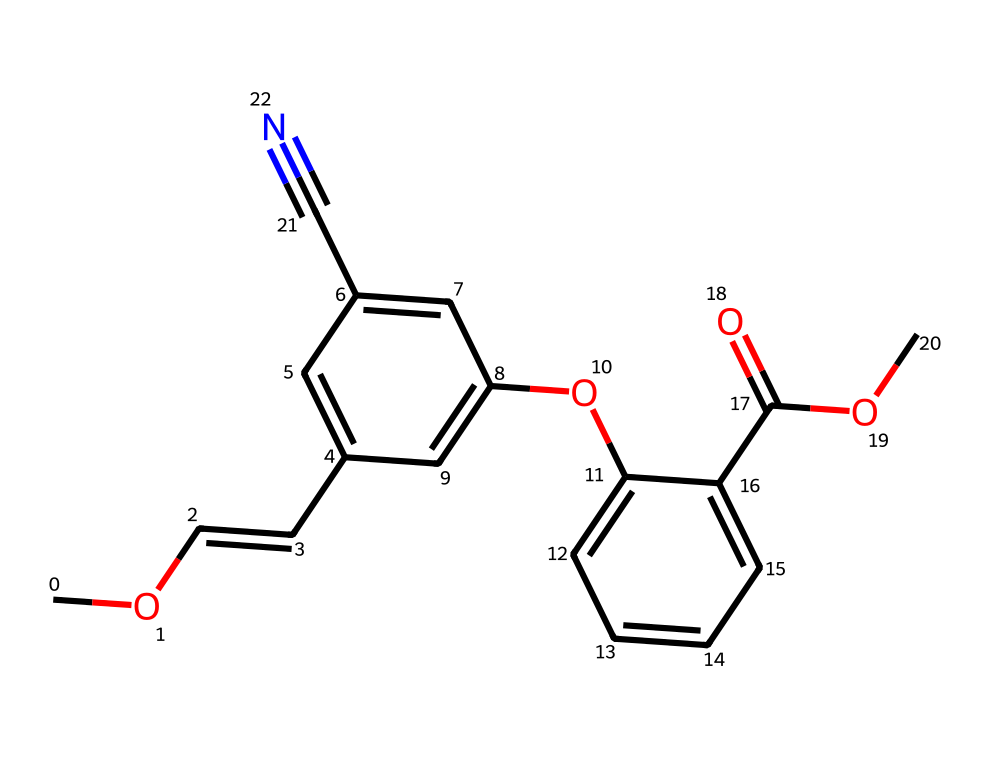What is the molecular formula of azoxystrobin? To determine the molecular formula, we identify and count the various atoms present in the provided SMILES representation. The key elements in the structure include carbon (C), hydrogen (H), oxygen (O), and nitrogen (N). Counting the atoms gives us a formula of C18H18N2O4.
Answer: C18H18N2O4 How many rings are present in the chemical structure of azoxystrobin? By examining the structure in the SMILES notation, we see two cyclic components, specifically located in the occluded aromatic rings. Each benzene-like structure contributes to the total ring count.
Answer: 2 What type of functional groups are present in azoxystrobin? The SMILES includes several functional groups such as an ester group (due to the presence of -COOC) and a cyano group (-C#N). The esters are indicated with the carbon-oxygen bonds and the cyano group is identified by the terminal triple bond with nitrogen.
Answer: ester, cyano What is the significance of the cyano group in azoxystrobin? The cyano group (-C#N) plays a role in the biological activity of azoxystrobin, influencing its toxicity and efficacy against fungal pathogens. It increases the lipophilicity, aiding the penetration of the molecule into fungal cells.
Answer: biological activity Which parts of the azoxystrobin structure are likely responsible for its fungicidal properties? Analyzing the chemical structure and its functional groups, both the aromatic ring system and cyano group contribute to its mechanism of action, specifically through their interactions with fungal enzymes. The steric and electronic properties of these groups help inhibit the fungi's metabolic pathways.
Answer: aromatic ring, cyano group How many oxygen atoms are in the azoxystrobin structure? A careful count of the oxygen atoms in the chemical structure reveals that there are four oxygen atoms present, characterized by the -O- in the ester groups and the presence in any attached groups.
Answer: 4 